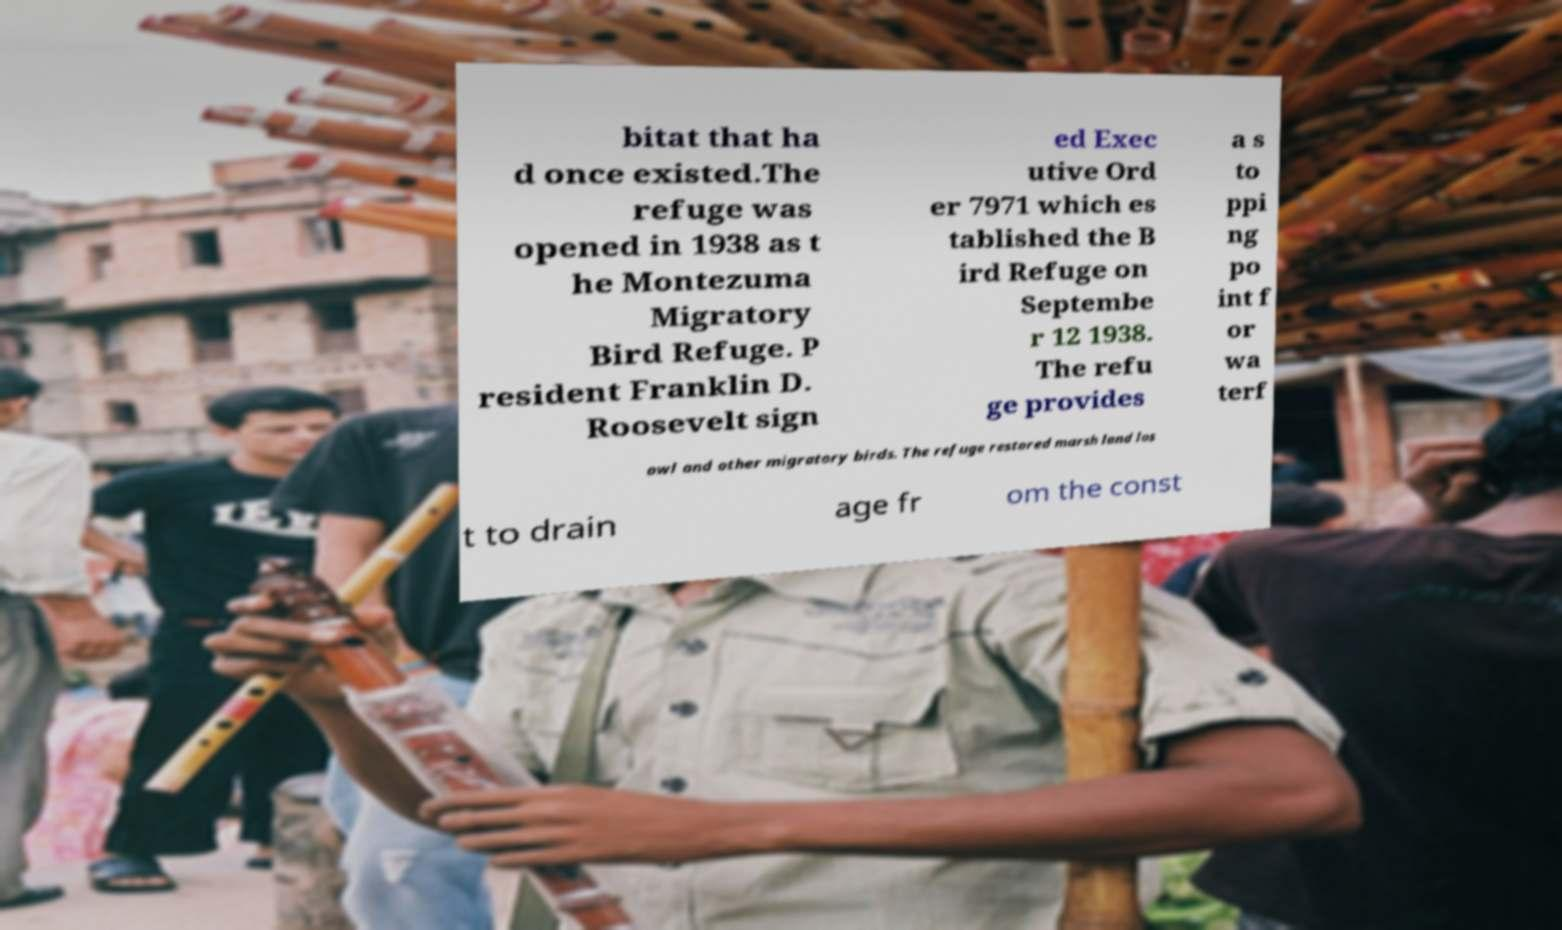Please read and relay the text visible in this image. What does it say? bitat that ha d once existed.The refuge was opened in 1938 as t he Montezuma Migratory Bird Refuge. P resident Franklin D. Roosevelt sign ed Exec utive Ord er 7971 which es tablished the B ird Refuge on Septembe r 12 1938. The refu ge provides a s to ppi ng po int f or wa terf owl and other migratory birds. The refuge restored marsh land los t to drain age fr om the const 